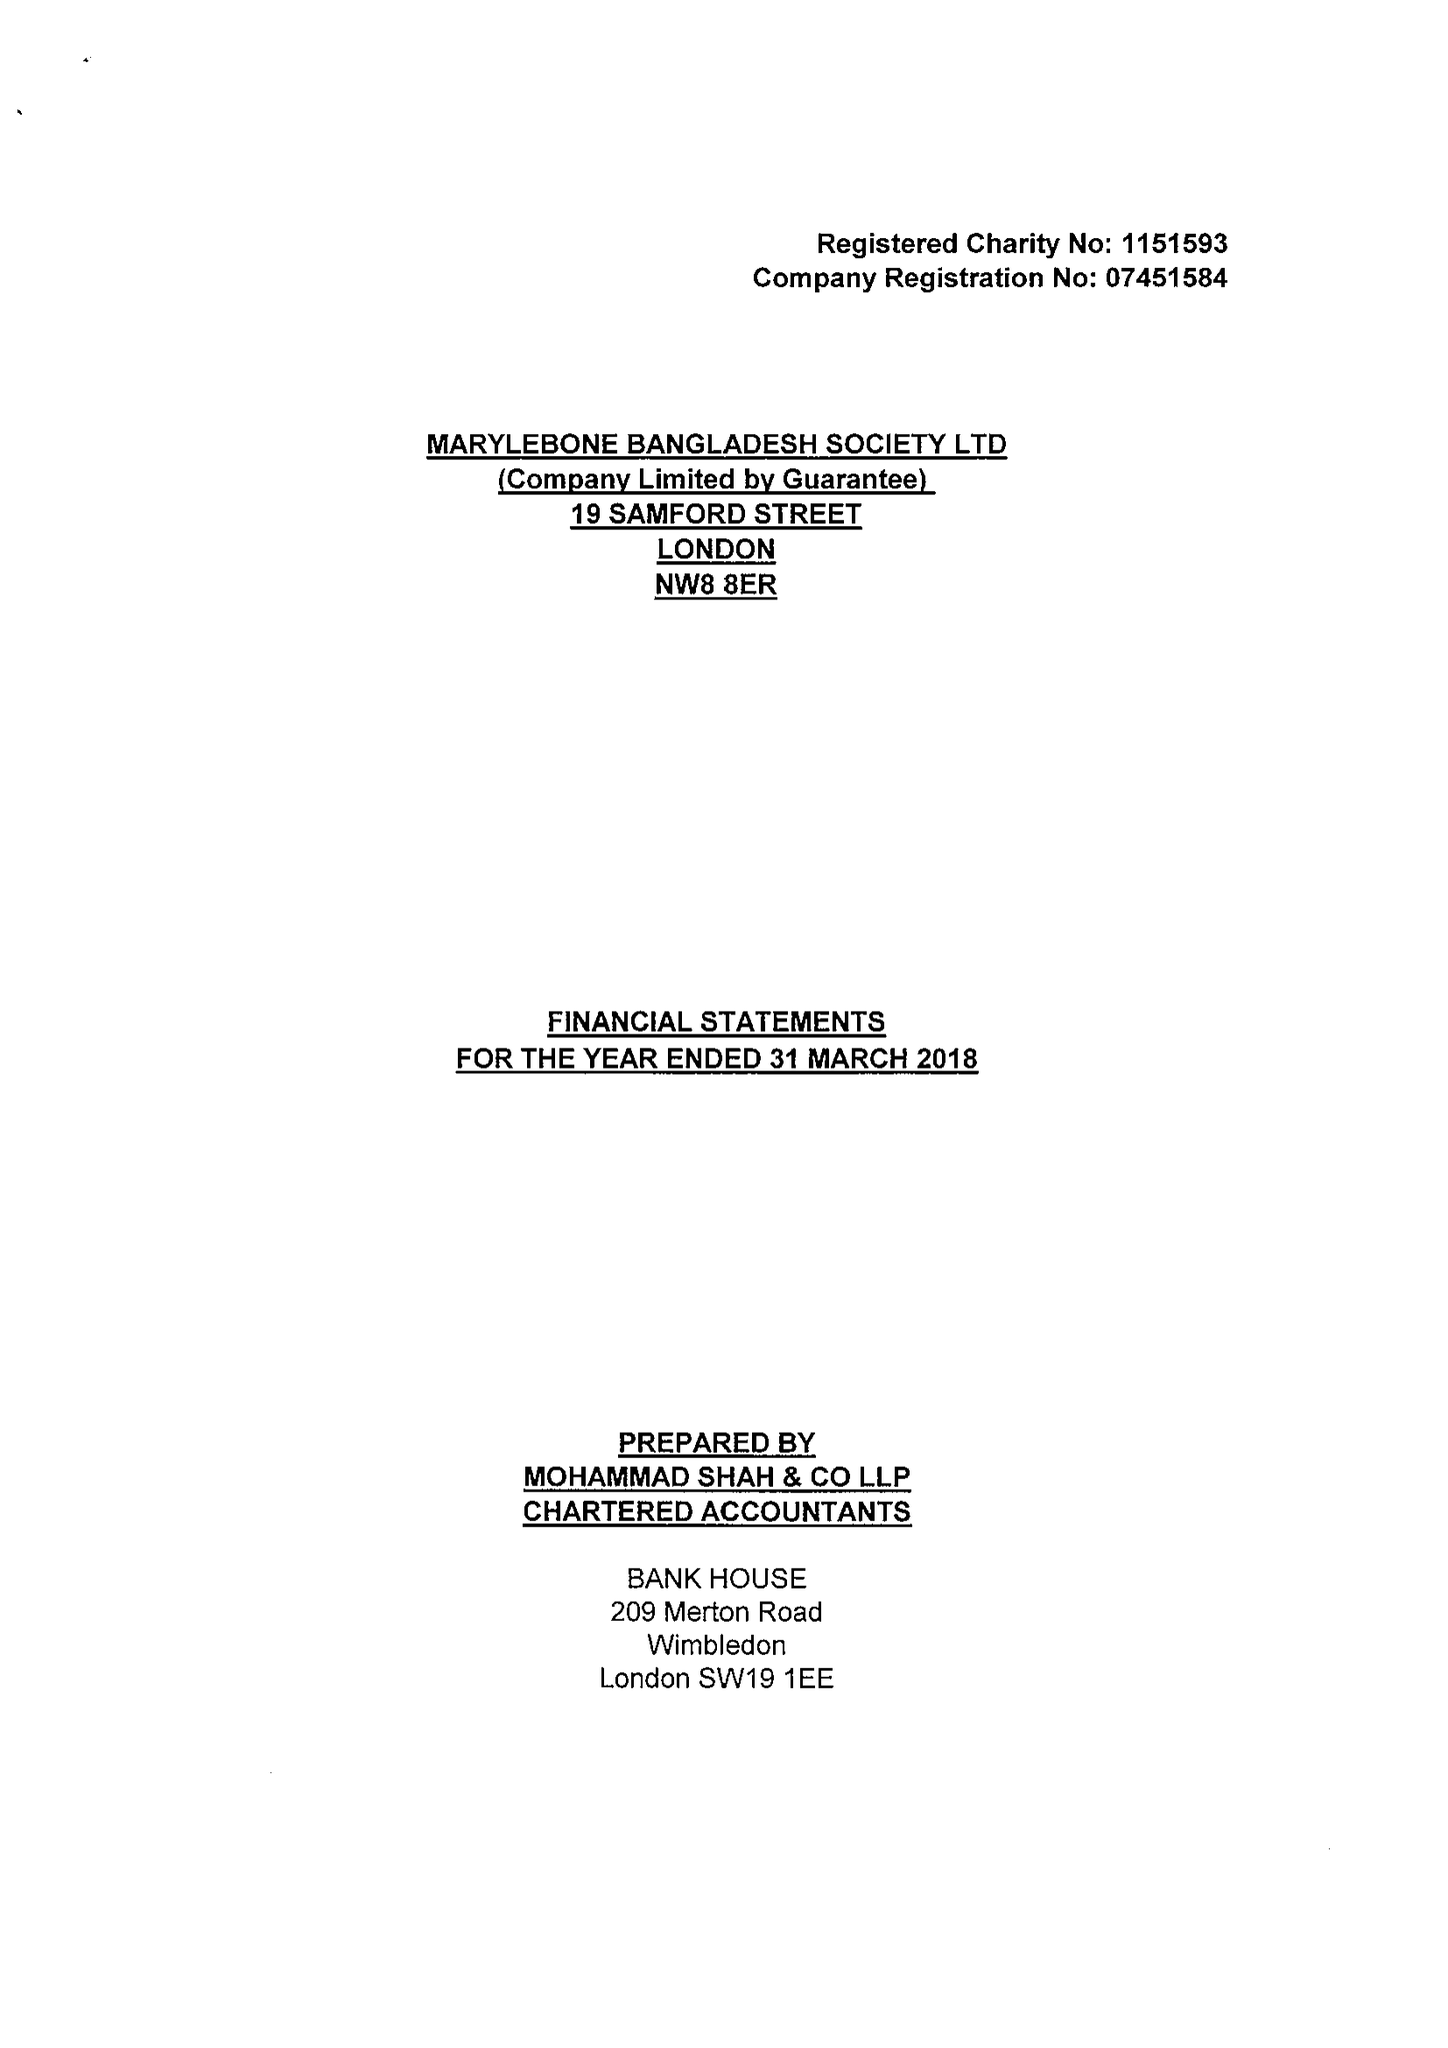What is the value for the address__postcode?
Answer the question using a single word or phrase. NW8 8ER 